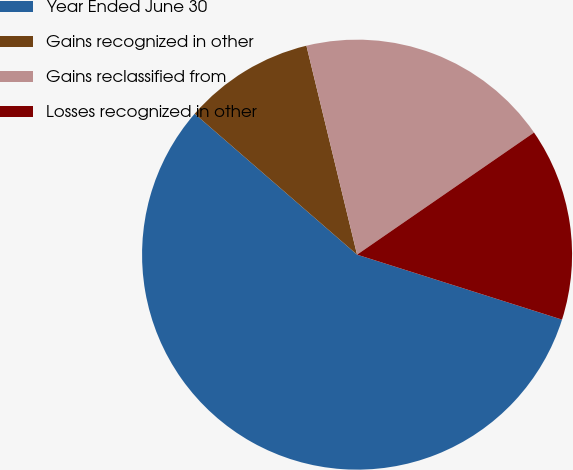<chart> <loc_0><loc_0><loc_500><loc_500><pie_chart><fcel>Year Ended June 30<fcel>Gains recognized in other<fcel>Gains reclassified from<fcel>Losses recognized in other<nl><fcel>56.49%<fcel>9.84%<fcel>19.17%<fcel>14.5%<nl></chart> 